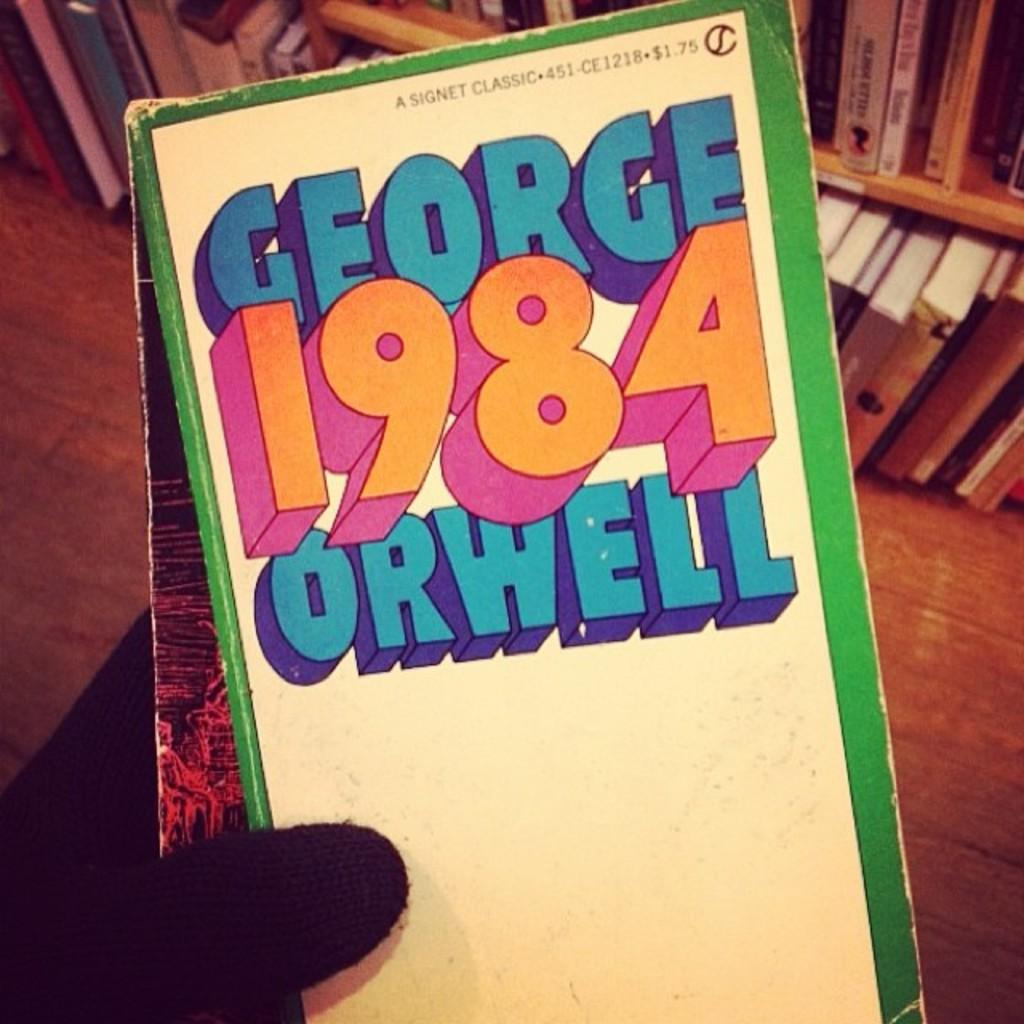<image>
Provide a brief description of the given image. Someone in gloves holds a book titled 1984. 